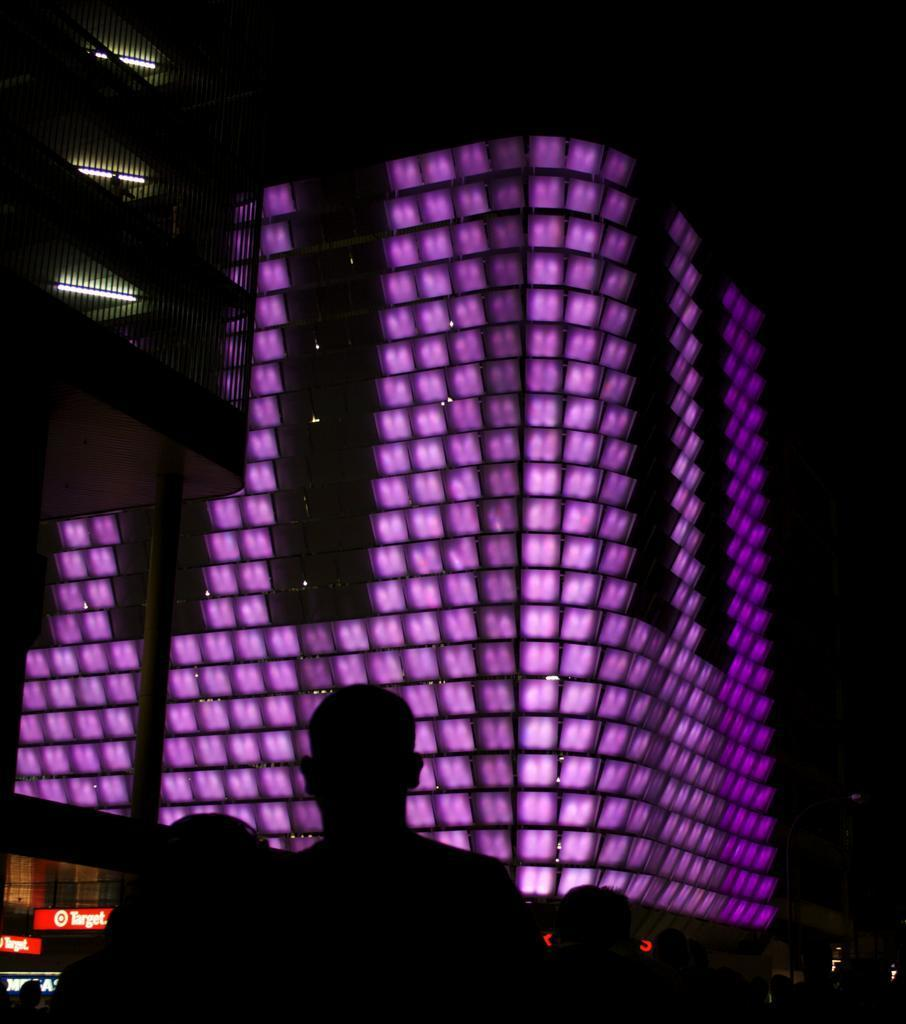What is the main structure in the center of the image? There is a building in the center of the image. What can be seen on or around the building in the image? There are lights in the center of the image. Who or what is located at the bottom of the image? There are people at the bottom of the image. What type of objects are present in the image? There are boards in the image. Are there any other structures visible in the image? Yes, there are additional buildings in the image. Can you tell me how many stems are attached to the person in the image? There is no person present in the image, and therefore no stems can be attached to them. What type of engine is powering the building in the image? The image does not provide information about an engine powering the building; it only shows the building and its surroundings. 